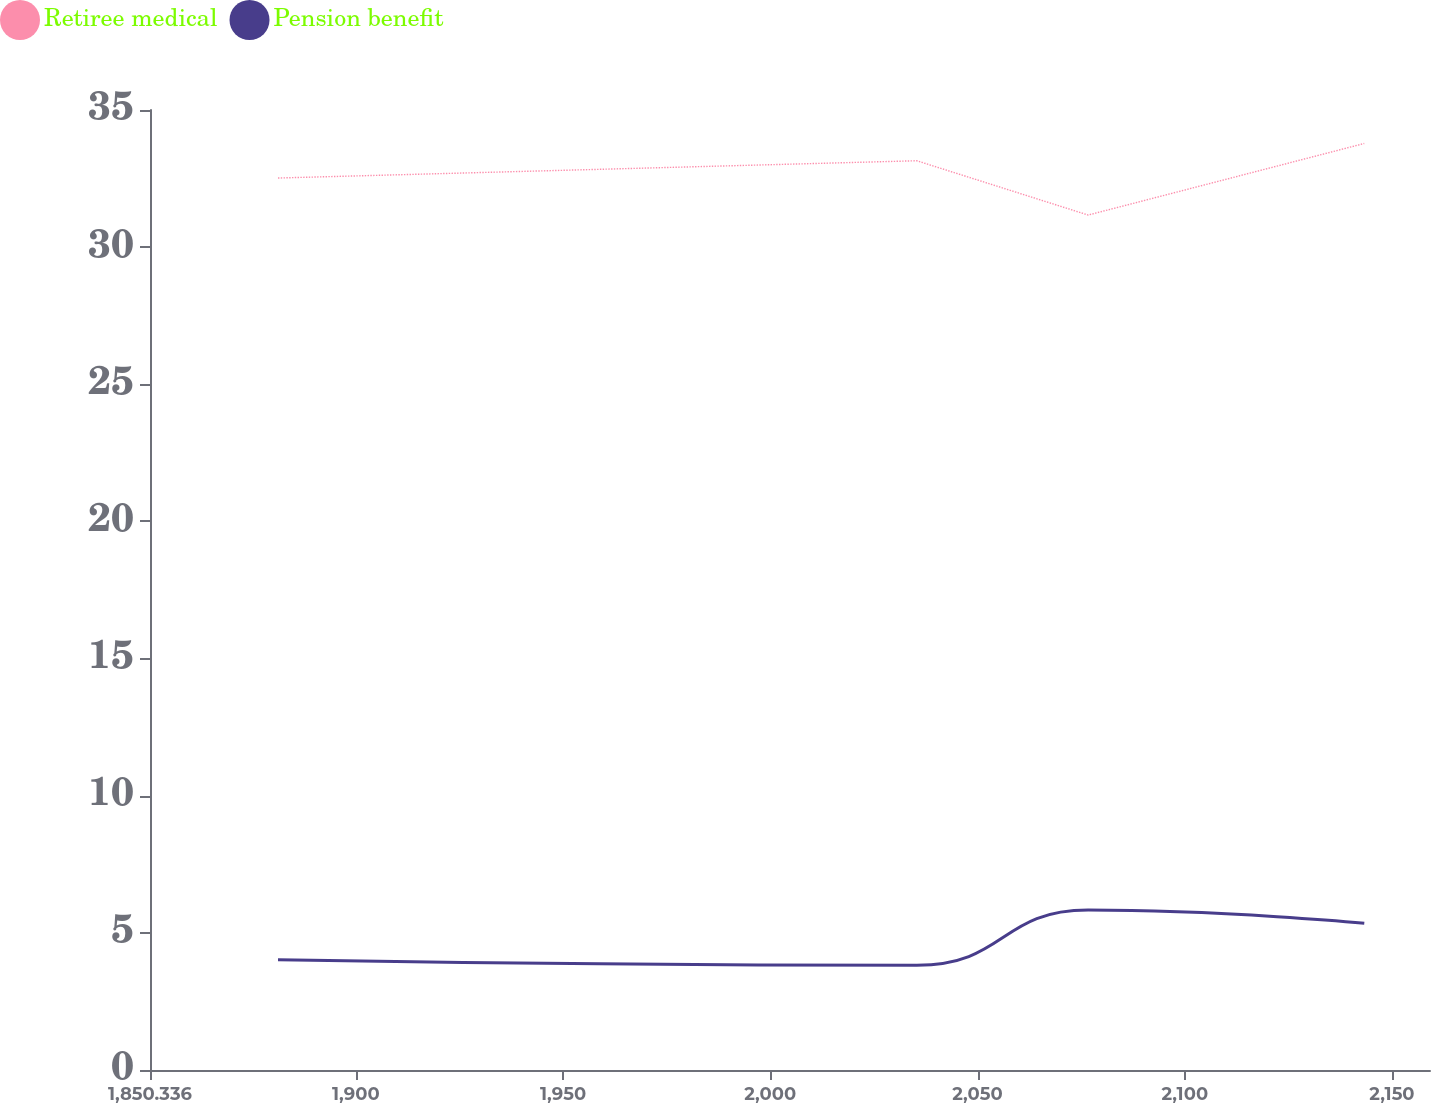Convert chart. <chart><loc_0><loc_0><loc_500><loc_500><line_chart><ecel><fcel>Retiree medical<fcel>Pension benefit<nl><fcel>1881.22<fcel>32.52<fcel>4.02<nl><fcel>2035.34<fcel>33.15<fcel>3.82<nl><fcel>2076.7<fcel>31.17<fcel>5.83<nl><fcel>2143.32<fcel>33.78<fcel>5.35<nl><fcel>2190.06<fcel>31.89<fcel>5.07<nl></chart> 